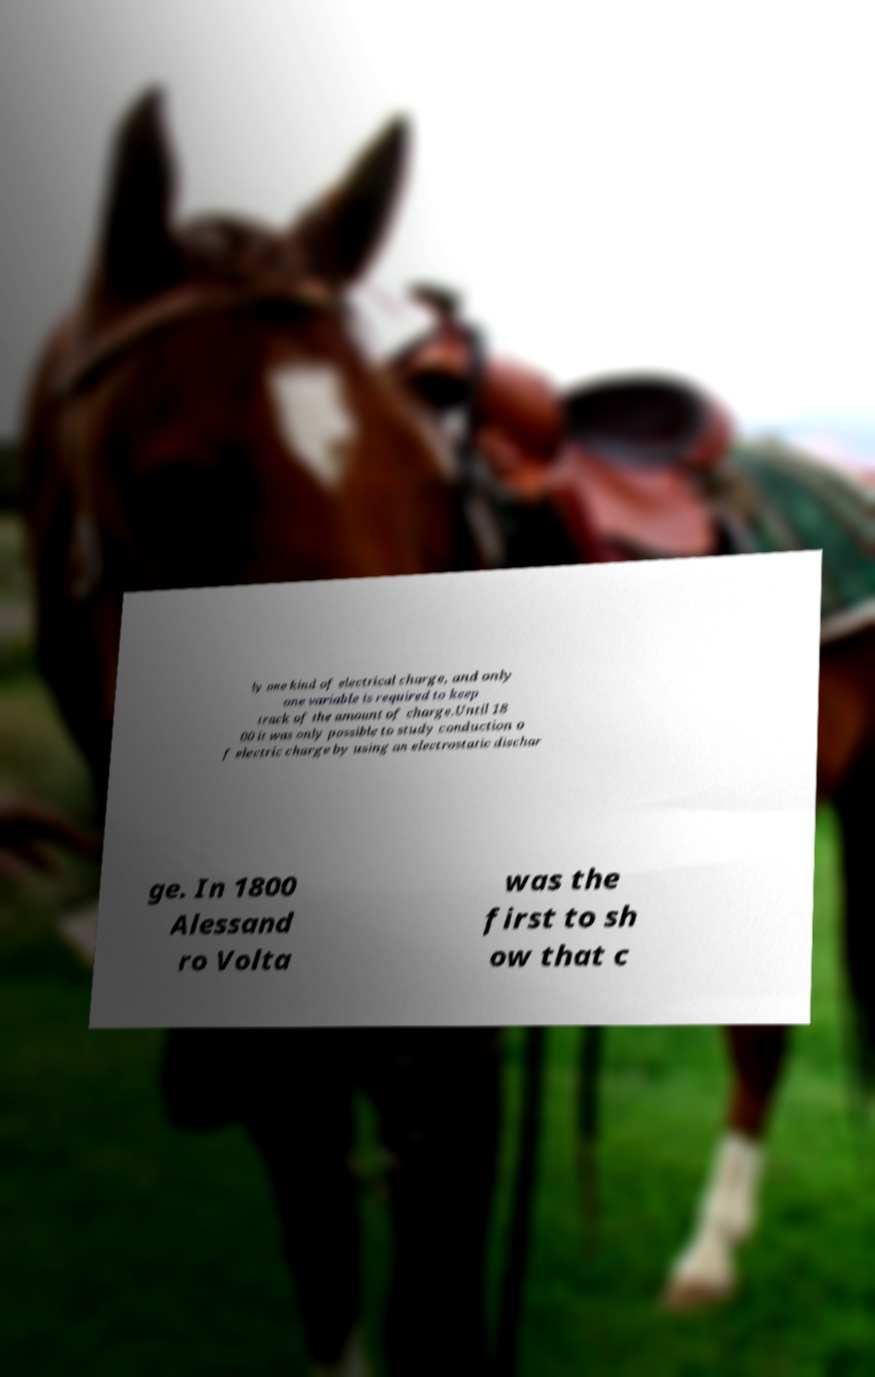Could you assist in decoding the text presented in this image and type it out clearly? ly one kind of electrical charge, and only one variable is required to keep track of the amount of charge.Until 18 00 it was only possible to study conduction o f electric charge by using an electrostatic dischar ge. In 1800 Alessand ro Volta was the first to sh ow that c 